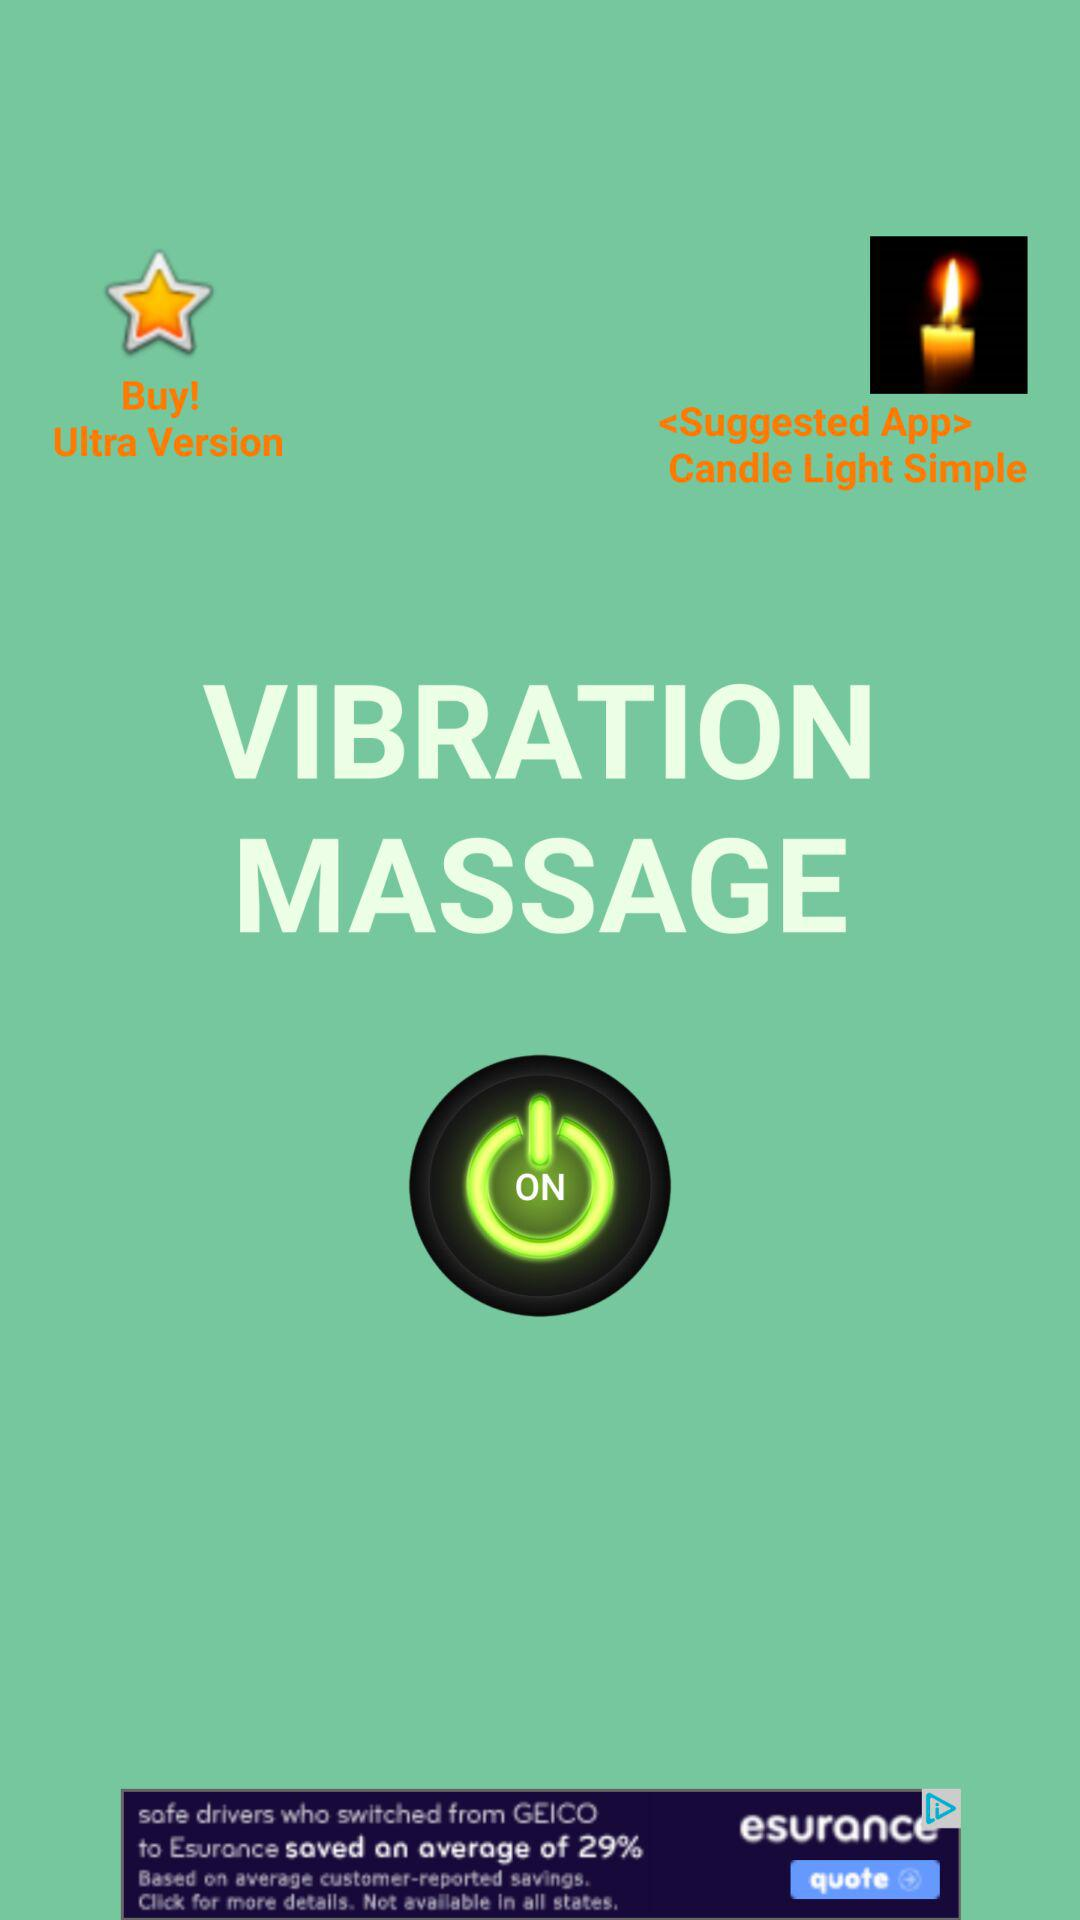What massage is currently "ON"? It is the vibration massage. 